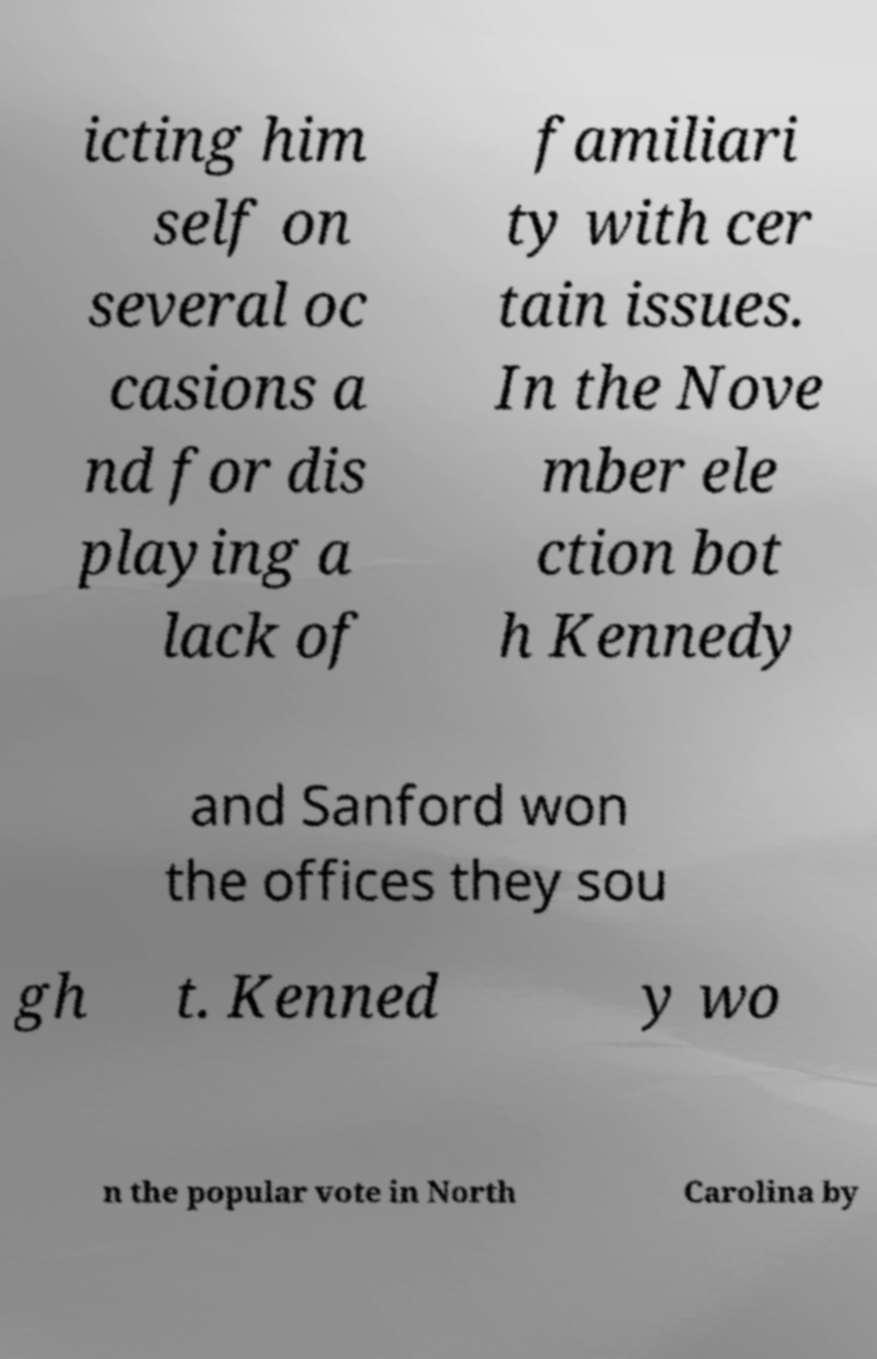I need the written content from this picture converted into text. Can you do that? icting him self on several oc casions a nd for dis playing a lack of familiari ty with cer tain issues. In the Nove mber ele ction bot h Kennedy and Sanford won the offices they sou gh t. Kenned y wo n the popular vote in North Carolina by 